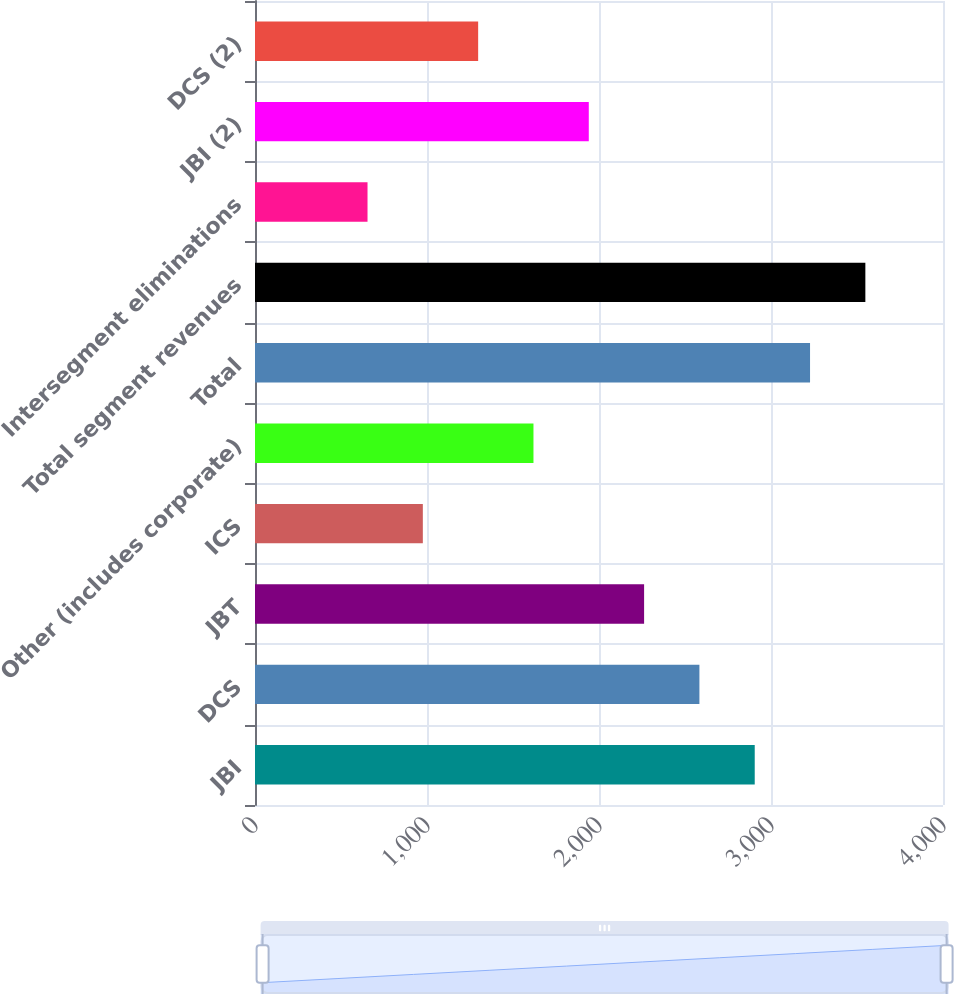Convert chart to OTSL. <chart><loc_0><loc_0><loc_500><loc_500><bar_chart><fcel>JBI<fcel>DCS<fcel>JBT<fcel>ICS<fcel>Other (includes corporate)<fcel>Total<fcel>Total segment revenues<fcel>Intersegment eliminations<fcel>JBI (2)<fcel>DCS (2)<nl><fcel>2905.4<fcel>2583.8<fcel>2262.2<fcel>975.8<fcel>1619<fcel>3227<fcel>3548.6<fcel>654.2<fcel>1940.6<fcel>1297.4<nl></chart> 